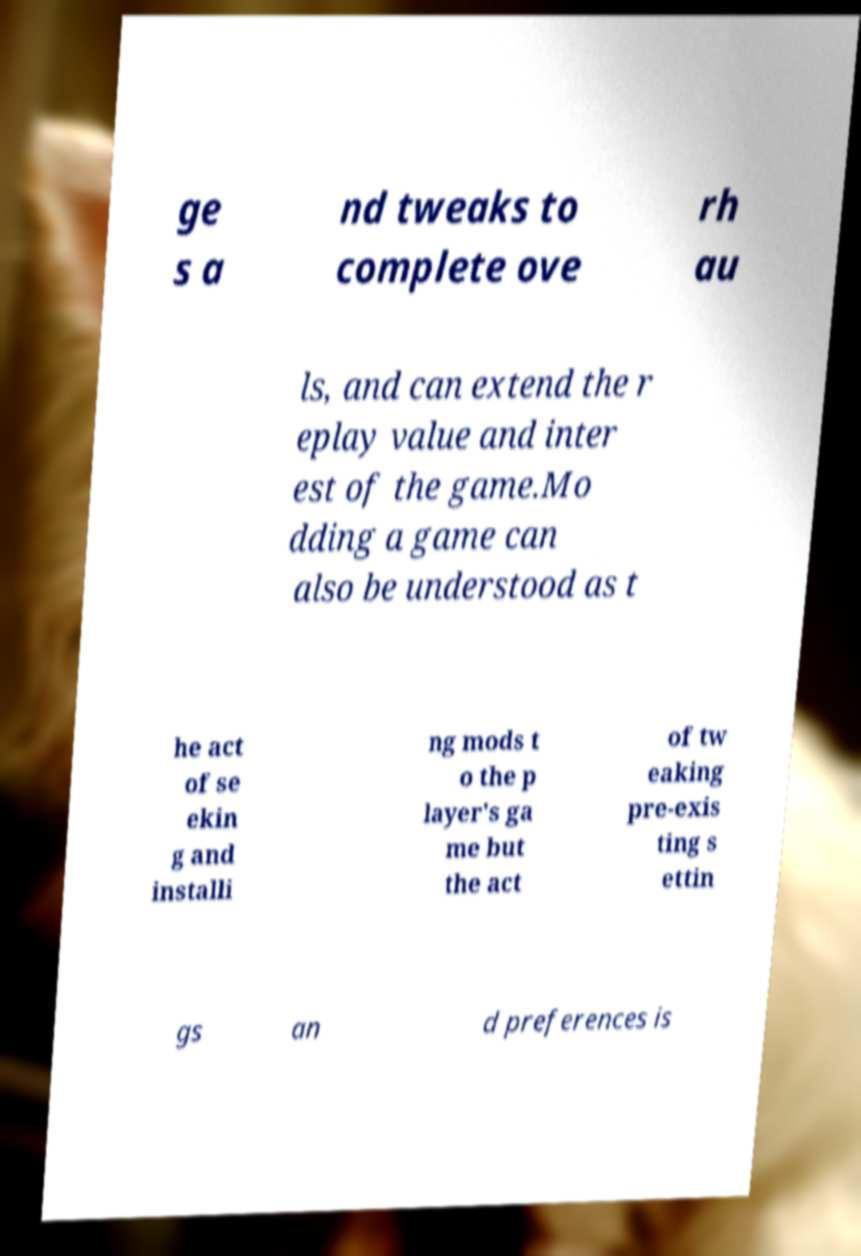There's text embedded in this image that I need extracted. Can you transcribe it verbatim? ge s a nd tweaks to complete ove rh au ls, and can extend the r eplay value and inter est of the game.Mo dding a game can also be understood as t he act of se ekin g and installi ng mods t o the p layer's ga me but the act of tw eaking pre-exis ting s ettin gs an d preferences is 